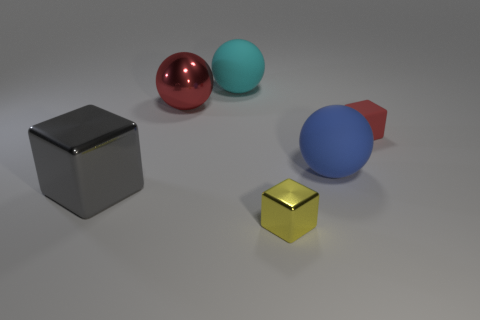There is a shiny cube in front of the big object that is left of the large red thing; how big is it? The shiny cube appears to be relatively small, especially when compared to the surrounding objects. It's situated in front of a larger object, which is to the left of a sizable red sphere. While exact dimensions are not discernible from the image alone, it can be inferred that the cube is a small, possibly decorative item amidst larger geometric shapes. 